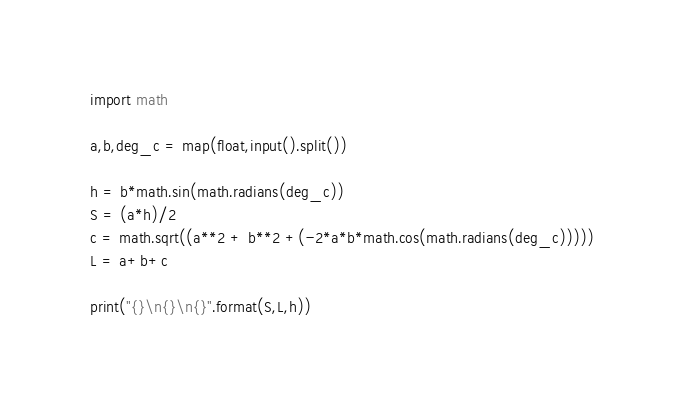<code> <loc_0><loc_0><loc_500><loc_500><_Python_>import math

a,b,deg_c = map(float,input().split())

h = b*math.sin(math.radians(deg_c))
S = (a*h)/2
c = math.sqrt((a**2 + b**2 +(-2*a*b*math.cos(math.radians(deg_c)))))
L = a+b+c

print("{}\n{}\n{}".format(S,L,h))
</code> 